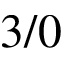Convert formula to latex. <formula><loc_0><loc_0><loc_500><loc_500>3 / 0</formula> 